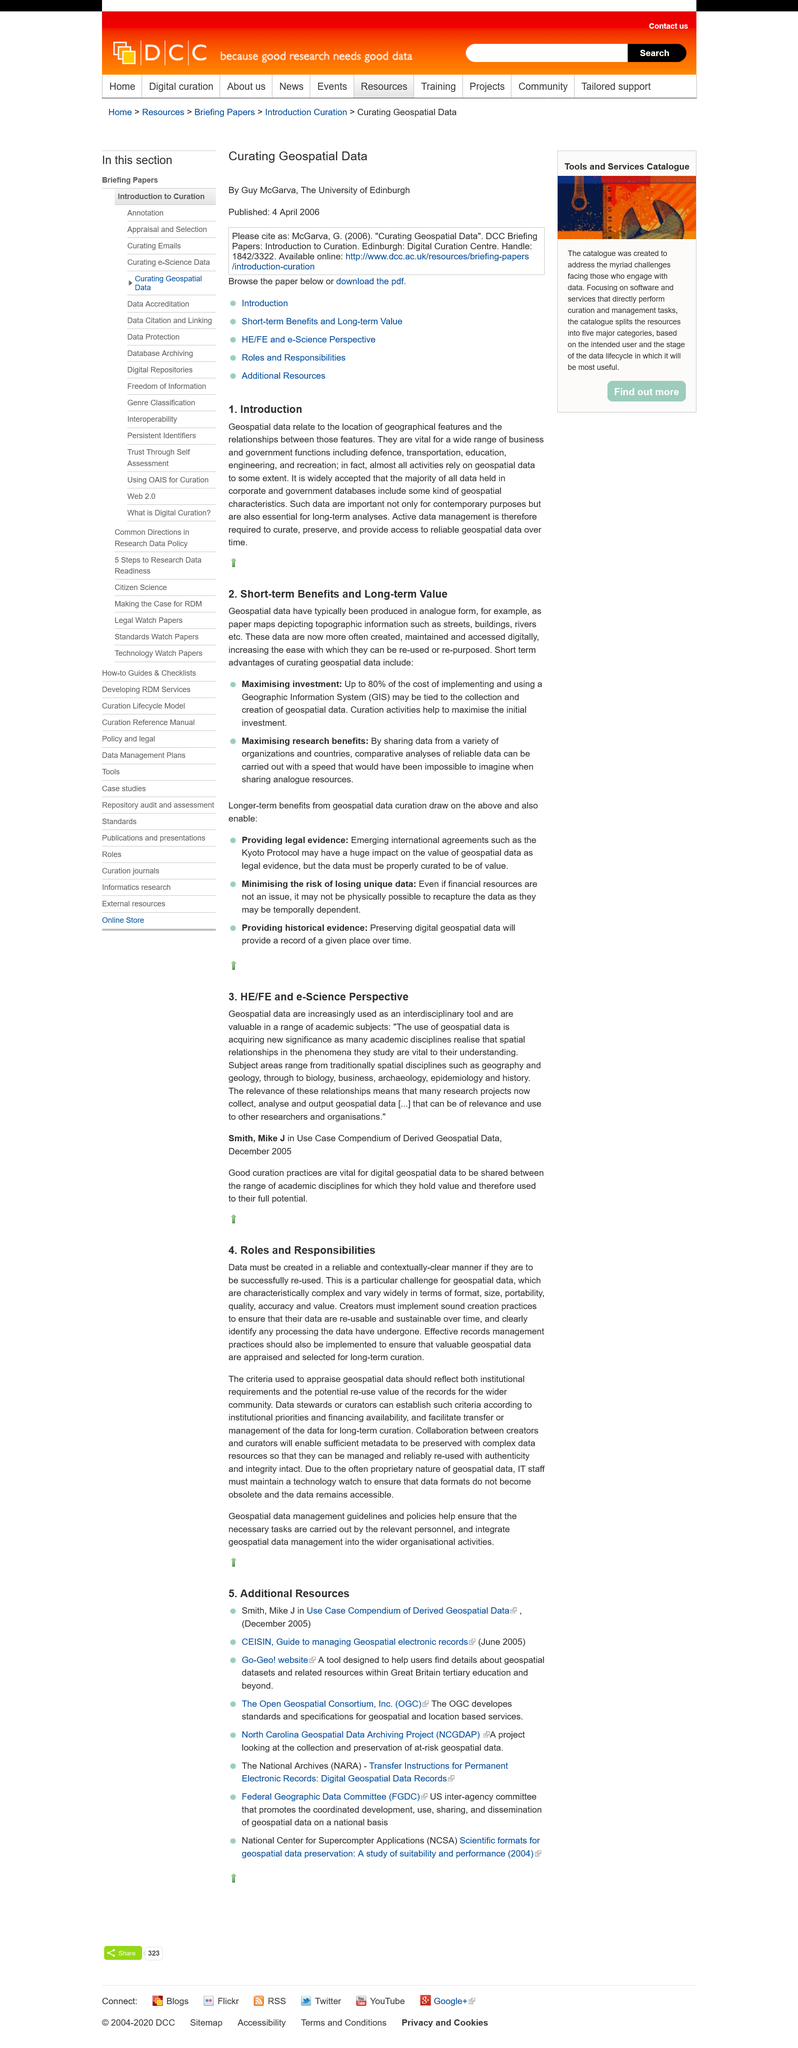Mention a couple of crucial points in this snapshot. The title of the subheading is "Introduction". Yes, geospatial data is vital for a wide range of business and government functions. Geospatial data is concerned with the location and relationship of geographical features. It provides information about the position, shape, and characteristics of these features, as well as the ways in which they interact with each other and their environment. This information is used to better understand the Earth's physical and human systems, and to support decision-making in a wide range of fields, including planning, transportation, emergency response, and resource management. 